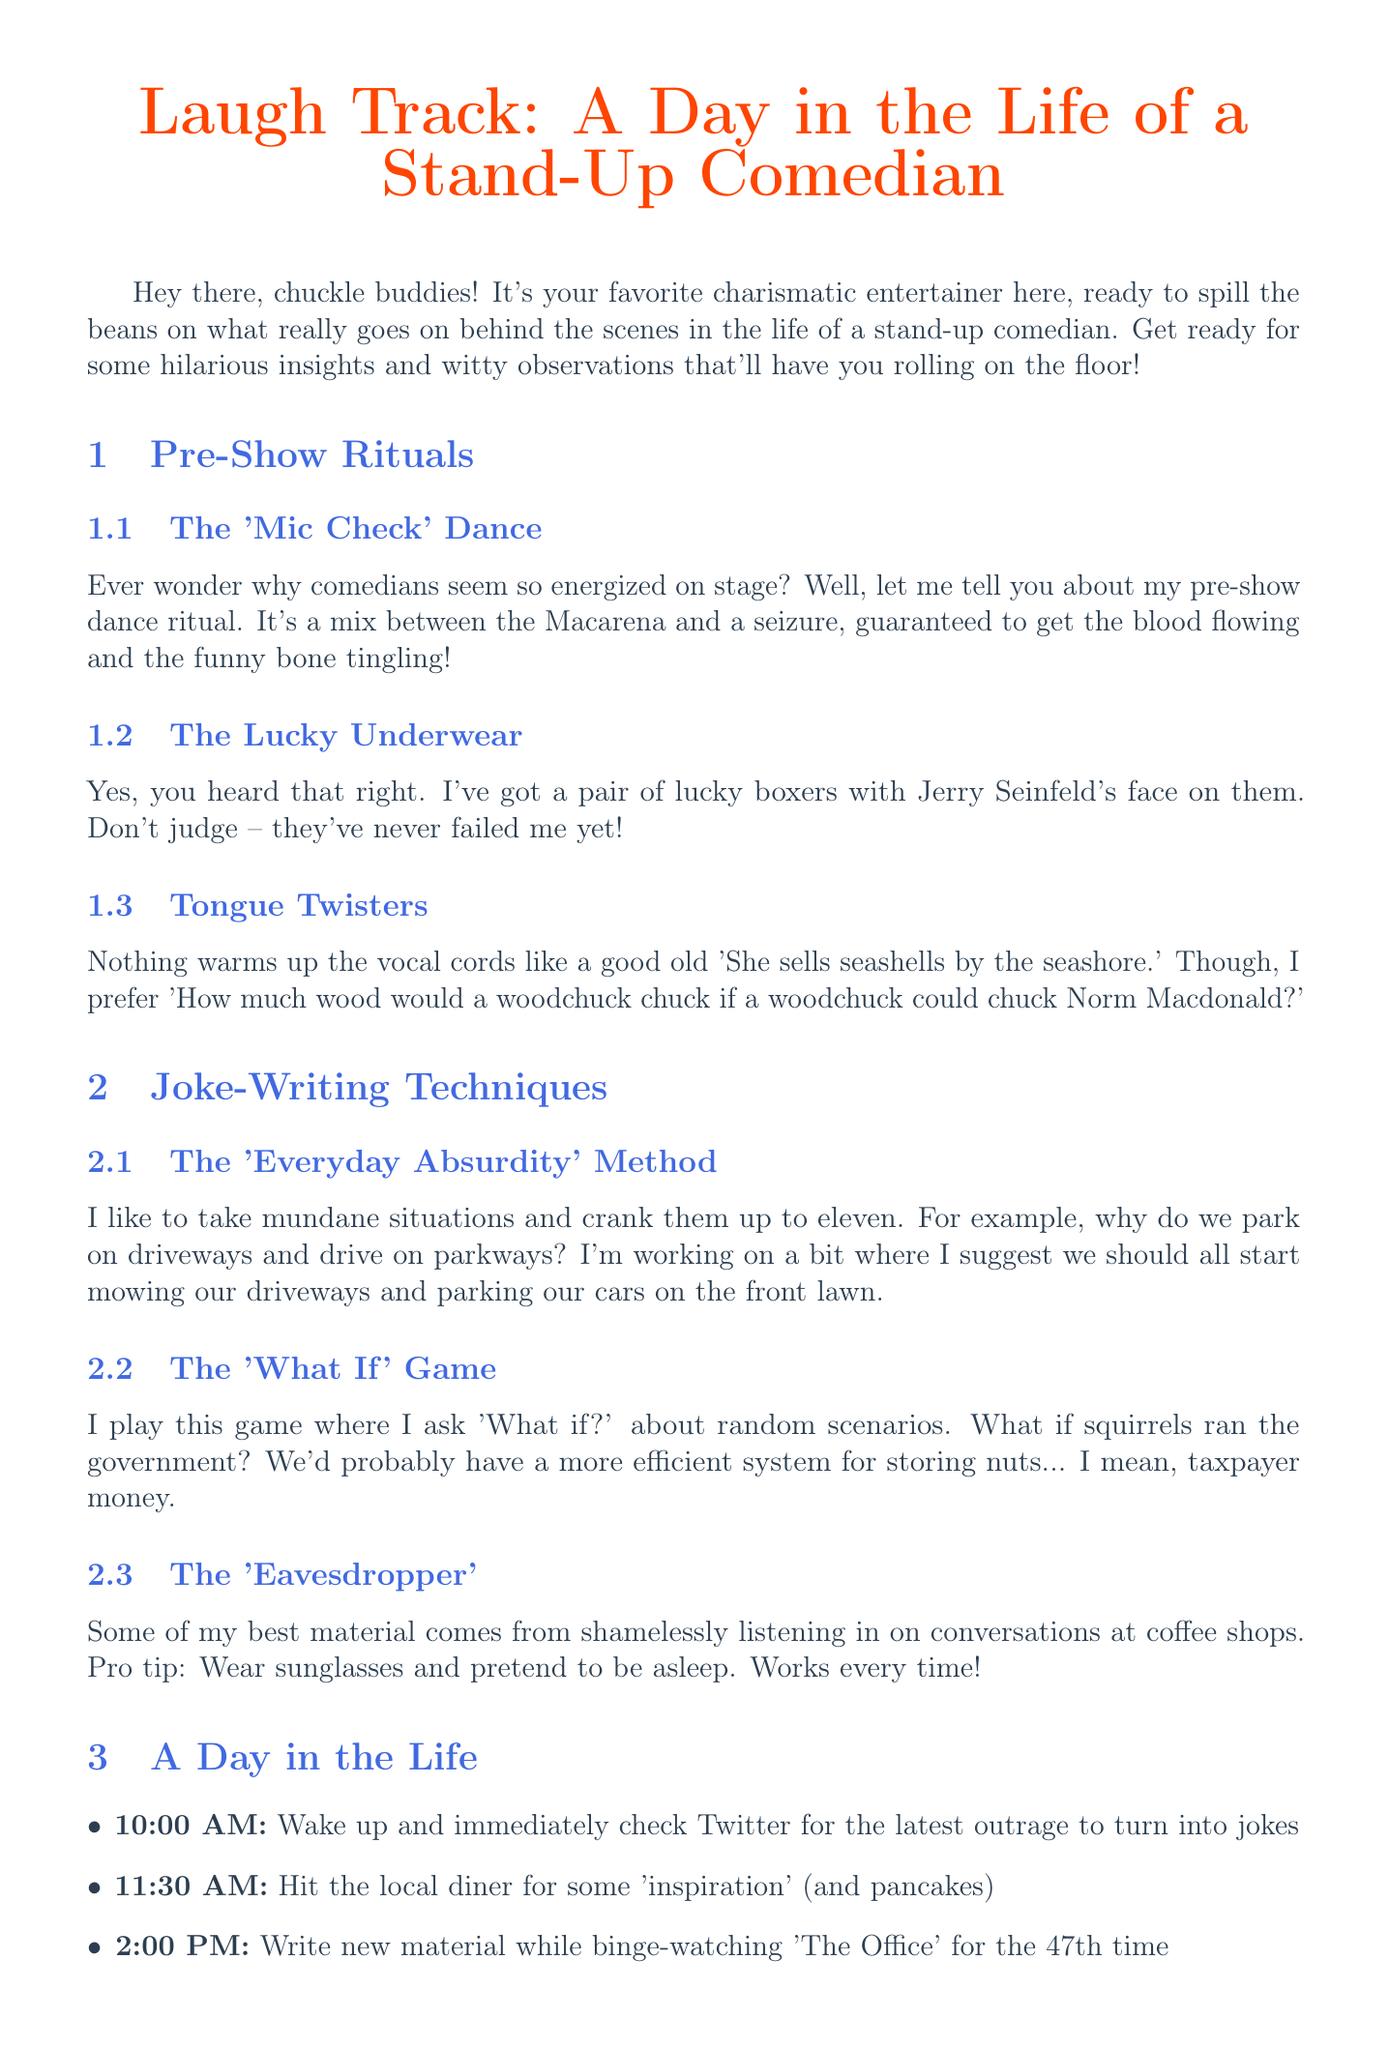What is the title of the newsletter? The title of the newsletter is prominently displayed at the top of the document.
Answer: Laugh Track: A Day in the Life of a Stand-Up Comedian Who is the famous comedian quoted in the document? The document cites a well-known comedian for a motivational quote.
Answer: Steve Martin What time does the comedian wake up? The comedian's schedule lists the first activity of the day at a specific time.
Answer: 10:00 AM What is one of the pre-show rituals mentioned? The document provides several examples of rituals performed before a show.
Answer: The 'Mic Check' Dance What method involves asking "What if?" about scenarios? The joke-writing techniques section describes different methods for creating humor.
Answer: The 'What If' Game What should you wear while eavesdropping according to the document? The document suggests a disguise for a specific technique used by the comedian.
Answer: Sunglasses At what place does the comedian analyze the show post-performance? The schedule details where the comedian discusses the show after performing.
Answer: The bar What is the final message in the conclusion paragraph? The document encourages a positive perspective toward laughter and humor.
Answer: Stay funny, my friends! 